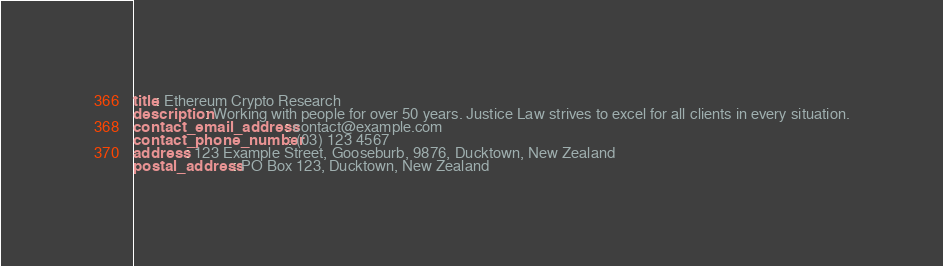Convert code to text. <code><loc_0><loc_0><loc_500><loc_500><_YAML_>title: Ethereum Crypto Research 
description: Working with people for over 50 years. Justice Law strives to excel for all clients in every situation.
contact_email_address: contact@example.com
contact_phone_number: (03) 123 4567
address: 123 Example Street, Gooseburb, 9876, Ducktown, New Zealand
postal_address: PO Box 123, Ducktown, New Zealand
</code> 